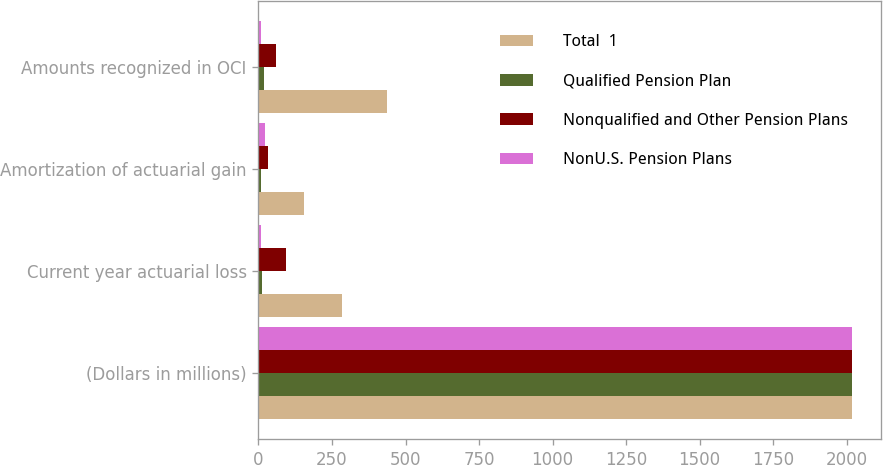Convert chart. <chart><loc_0><loc_0><loc_500><loc_500><stacked_bar_chart><ecel><fcel>(Dollars in millions)<fcel>Current year actuarial loss<fcel>Amortization of actuarial gain<fcel>Amounts recognized in OCI<nl><fcel>Total  1<fcel>2017<fcel>283<fcel>154<fcel>437<nl><fcel>Qualified Pension Plan<fcel>2017<fcel>12<fcel>8<fcel>20<nl><fcel>Nonqualified and Other Pension Plans<fcel>2017<fcel>95<fcel>34<fcel>61<nl><fcel>NonU.S. Pension Plans<fcel>2017<fcel>7<fcel>21<fcel>9<nl></chart> 